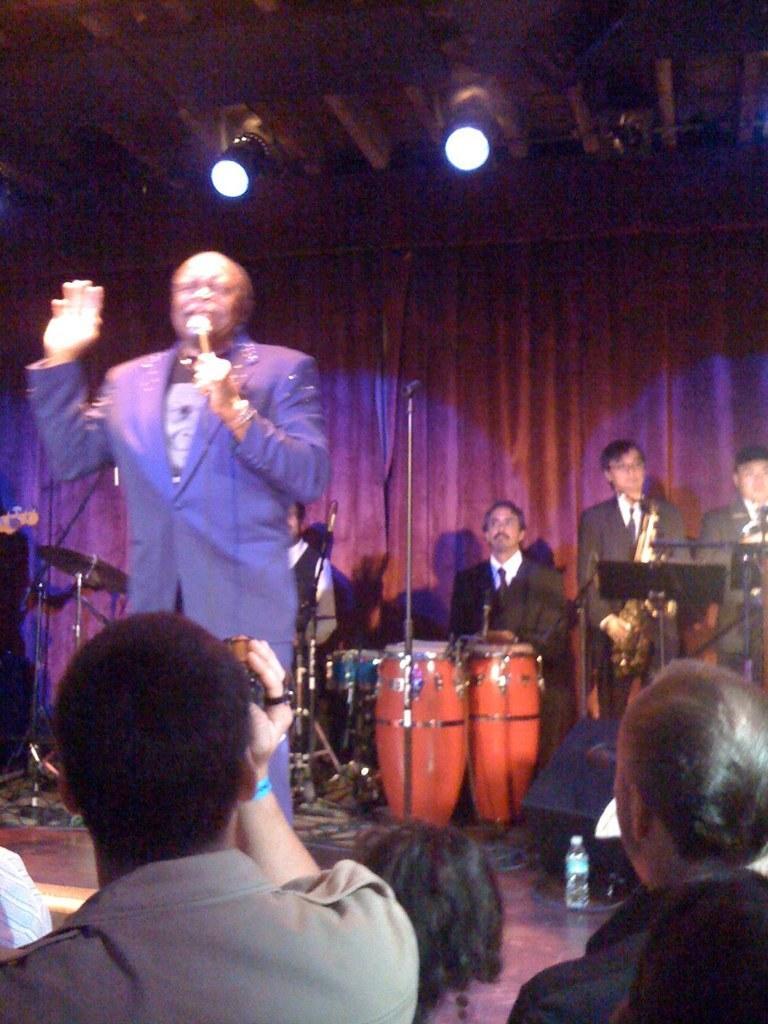Please provide a concise description of this image. In the image we can see few persons on the stage. Here in the center he is singing and holding microphone. And back of him they were playing with musical instruments. And in the bottom they were audience. 